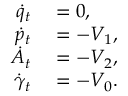<formula> <loc_0><loc_0><loc_500><loc_500>\begin{array} { r l } { \dot { q } _ { t } } & = 0 , } \\ { \dot { p } _ { t } } & = - V _ { 1 } , } \\ { \dot { A } _ { t } } & = - V _ { 2 } , } \\ { \dot { \gamma } _ { t } } & = - V _ { 0 } . } \end{array}</formula> 